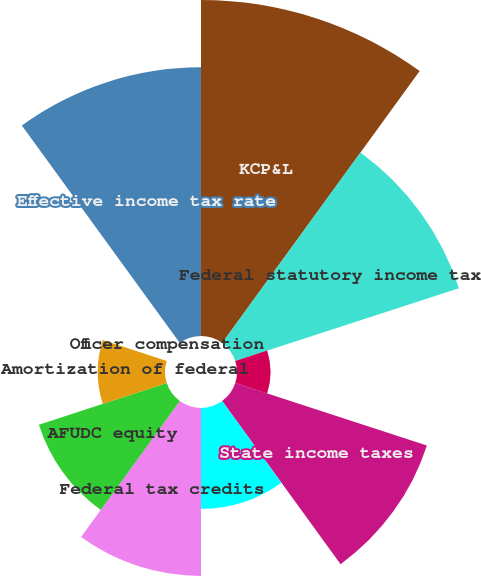<chart> <loc_0><loc_0><loc_500><loc_500><pie_chart><fcel>KCP&L<fcel>Federal statutory income tax<fcel>COLI policies<fcel>State income taxes<fcel>Flow through depreciation for<fcel>Federal tax credits<fcel>AFUDC equity<fcel>Amortization of federal<fcel>Officer compensation<fcel>Effective income tax rate<nl><fcel>21.74%<fcel>15.22%<fcel>2.17%<fcel>13.04%<fcel>6.52%<fcel>10.87%<fcel>8.7%<fcel>4.35%<fcel>0.0%<fcel>17.39%<nl></chart> 